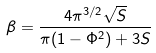Convert formula to latex. <formula><loc_0><loc_0><loc_500><loc_500>\beta = \frac { 4 \pi ^ { 3 / 2 } \sqrt { S } } { \pi ( 1 - \Phi ^ { 2 } ) + 3 S }</formula> 